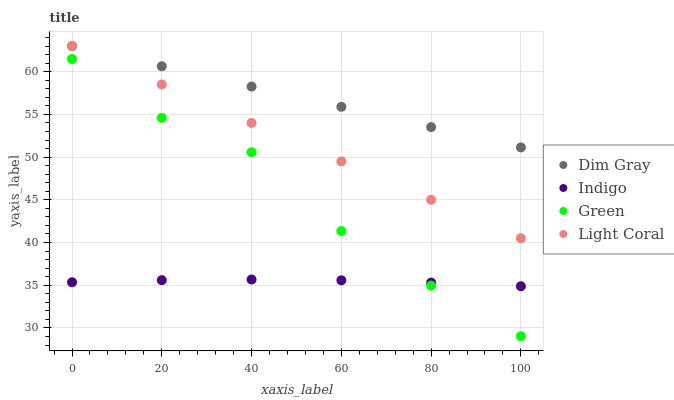Does Indigo have the minimum area under the curve?
Answer yes or no. Yes. Does Dim Gray have the maximum area under the curve?
Answer yes or no. Yes. Does Green have the minimum area under the curve?
Answer yes or no. No. Does Green have the maximum area under the curve?
Answer yes or no. No. Is Dim Gray the smoothest?
Answer yes or no. Yes. Is Green the roughest?
Answer yes or no. Yes. Is Green the smoothest?
Answer yes or no. No. Is Dim Gray the roughest?
Answer yes or no. No. Does Green have the lowest value?
Answer yes or no. Yes. Does Dim Gray have the lowest value?
Answer yes or no. No. Does Dim Gray have the highest value?
Answer yes or no. Yes. Does Green have the highest value?
Answer yes or no. No. Is Indigo less than Dim Gray?
Answer yes or no. Yes. Is Light Coral greater than Green?
Answer yes or no. Yes. Does Indigo intersect Green?
Answer yes or no. Yes. Is Indigo less than Green?
Answer yes or no. No. Is Indigo greater than Green?
Answer yes or no. No. Does Indigo intersect Dim Gray?
Answer yes or no. No. 